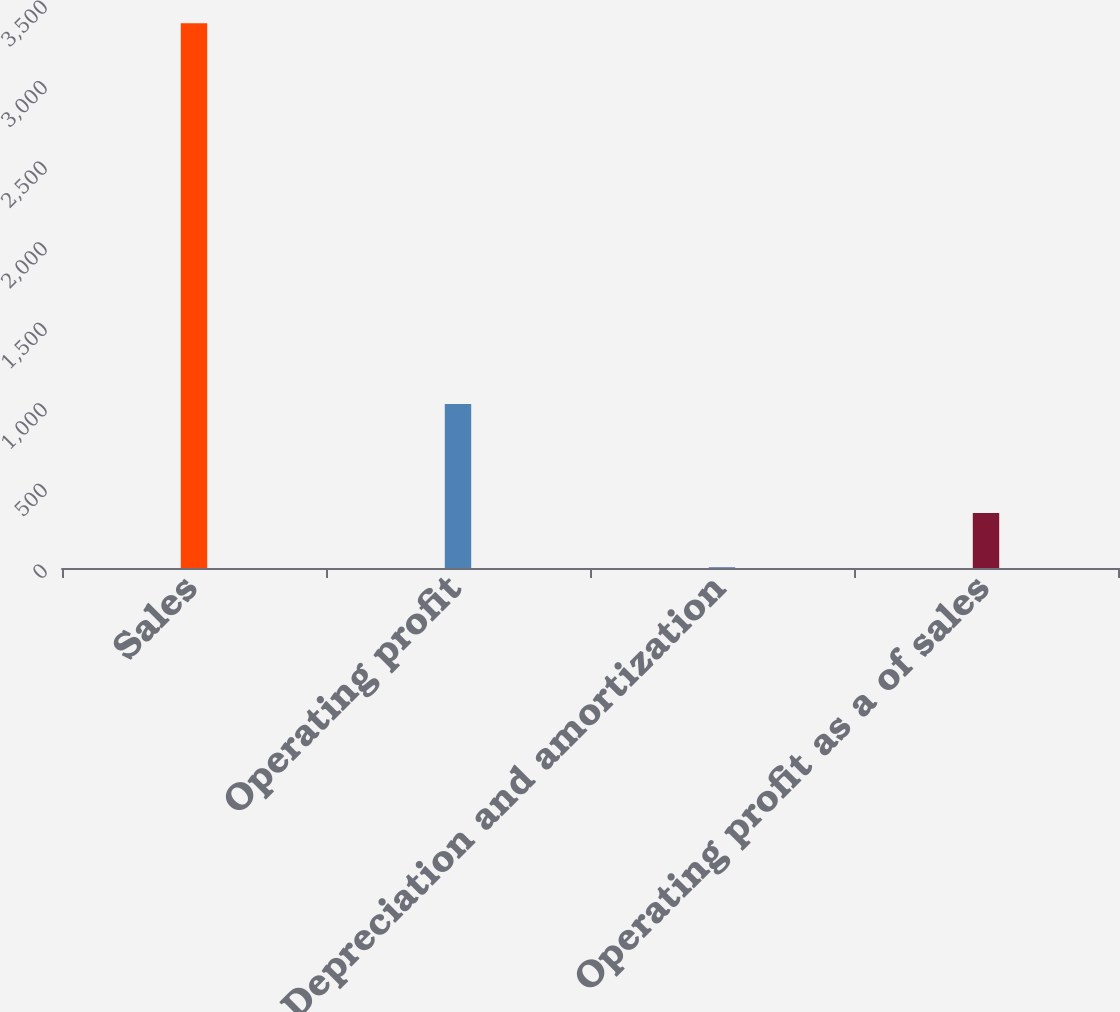<chart> <loc_0><loc_0><loc_500><loc_500><bar_chart><fcel>Sales<fcel>Operating profit<fcel>Depreciation and amortization<fcel>Operating profit as a of sales<nl><fcel>3381<fcel>1017.03<fcel>3.9<fcel>341.61<nl></chart> 